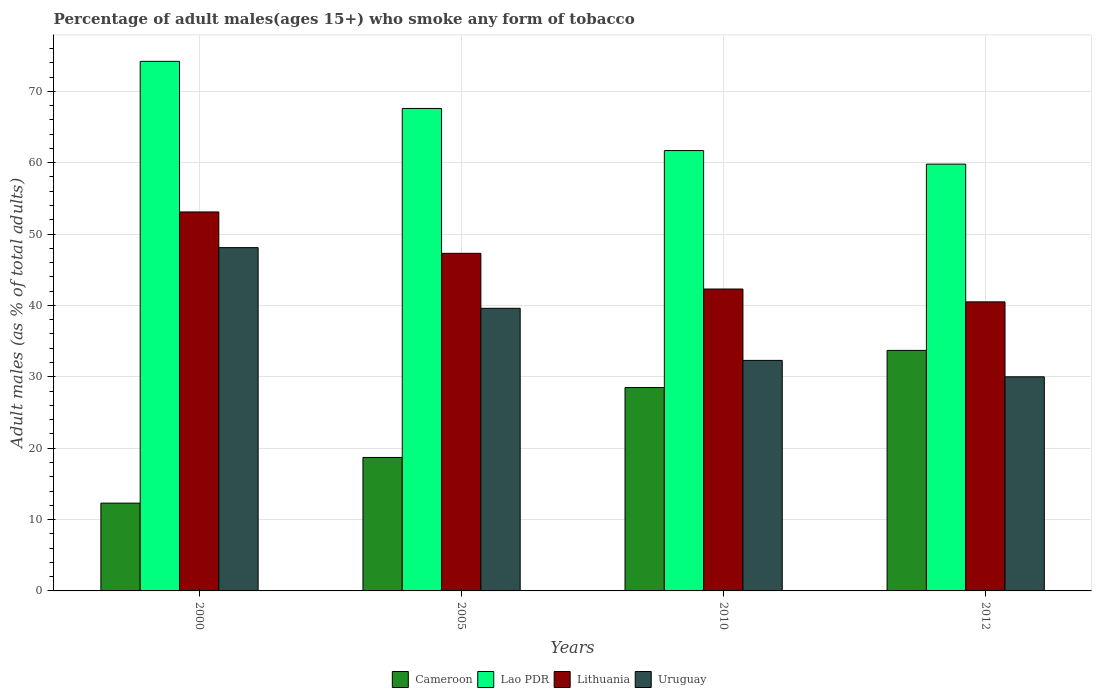How many different coloured bars are there?
Ensure brevity in your answer.  4. How many groups of bars are there?
Ensure brevity in your answer.  4. Are the number of bars per tick equal to the number of legend labels?
Your answer should be very brief. Yes. What is the label of the 3rd group of bars from the left?
Give a very brief answer. 2010. Across all years, what is the maximum percentage of adult males who smoke in Uruguay?
Your response must be concise. 48.1. Across all years, what is the minimum percentage of adult males who smoke in Cameroon?
Provide a short and direct response. 12.3. In which year was the percentage of adult males who smoke in Lao PDR maximum?
Provide a succinct answer. 2000. In which year was the percentage of adult males who smoke in Lithuania minimum?
Your answer should be very brief. 2012. What is the total percentage of adult males who smoke in Lithuania in the graph?
Your answer should be very brief. 183.2. What is the difference between the percentage of adult males who smoke in Uruguay in 2005 and the percentage of adult males who smoke in Lithuania in 2012?
Your answer should be compact. -0.9. What is the average percentage of adult males who smoke in Lithuania per year?
Provide a short and direct response. 45.8. In the year 2005, what is the difference between the percentage of adult males who smoke in Lithuania and percentage of adult males who smoke in Lao PDR?
Your answer should be very brief. -20.3. In how many years, is the percentage of adult males who smoke in Lao PDR greater than 66 %?
Your response must be concise. 2. What is the ratio of the percentage of adult males who smoke in Lithuania in 2000 to that in 2010?
Your answer should be very brief. 1.26. Is the percentage of adult males who smoke in Cameroon in 2005 less than that in 2012?
Your answer should be compact. Yes. Is the difference between the percentage of adult males who smoke in Lithuania in 2000 and 2005 greater than the difference between the percentage of adult males who smoke in Lao PDR in 2000 and 2005?
Provide a short and direct response. No. What is the difference between the highest and the second highest percentage of adult males who smoke in Lao PDR?
Your answer should be compact. 6.6. What is the difference between the highest and the lowest percentage of adult males who smoke in Uruguay?
Provide a succinct answer. 18.1. In how many years, is the percentage of adult males who smoke in Lithuania greater than the average percentage of adult males who smoke in Lithuania taken over all years?
Give a very brief answer. 2. Is the sum of the percentage of adult males who smoke in Cameroon in 2005 and 2012 greater than the maximum percentage of adult males who smoke in Uruguay across all years?
Give a very brief answer. Yes. Is it the case that in every year, the sum of the percentage of adult males who smoke in Uruguay and percentage of adult males who smoke in Lithuania is greater than the sum of percentage of adult males who smoke in Lao PDR and percentage of adult males who smoke in Cameroon?
Keep it short and to the point. No. What does the 1st bar from the left in 2000 represents?
Provide a short and direct response. Cameroon. What does the 2nd bar from the right in 2012 represents?
Provide a succinct answer. Lithuania. Is it the case that in every year, the sum of the percentage of adult males who smoke in Lithuania and percentage of adult males who smoke in Uruguay is greater than the percentage of adult males who smoke in Cameroon?
Ensure brevity in your answer.  Yes. How many bars are there?
Your response must be concise. 16. What is the difference between two consecutive major ticks on the Y-axis?
Give a very brief answer. 10. Are the values on the major ticks of Y-axis written in scientific E-notation?
Ensure brevity in your answer.  No. Does the graph contain any zero values?
Your answer should be compact. No. Where does the legend appear in the graph?
Ensure brevity in your answer.  Bottom center. How are the legend labels stacked?
Give a very brief answer. Horizontal. What is the title of the graph?
Your answer should be very brief. Percentage of adult males(ages 15+) who smoke any form of tobacco. What is the label or title of the X-axis?
Provide a short and direct response. Years. What is the label or title of the Y-axis?
Provide a succinct answer. Adult males (as % of total adults). What is the Adult males (as % of total adults) in Cameroon in 2000?
Your response must be concise. 12.3. What is the Adult males (as % of total adults) in Lao PDR in 2000?
Give a very brief answer. 74.2. What is the Adult males (as % of total adults) in Lithuania in 2000?
Your answer should be very brief. 53.1. What is the Adult males (as % of total adults) in Uruguay in 2000?
Offer a terse response. 48.1. What is the Adult males (as % of total adults) of Lao PDR in 2005?
Provide a succinct answer. 67.6. What is the Adult males (as % of total adults) in Lithuania in 2005?
Your answer should be very brief. 47.3. What is the Adult males (as % of total adults) of Uruguay in 2005?
Offer a very short reply. 39.6. What is the Adult males (as % of total adults) of Cameroon in 2010?
Provide a succinct answer. 28.5. What is the Adult males (as % of total adults) of Lao PDR in 2010?
Provide a short and direct response. 61.7. What is the Adult males (as % of total adults) of Lithuania in 2010?
Provide a short and direct response. 42.3. What is the Adult males (as % of total adults) in Uruguay in 2010?
Offer a terse response. 32.3. What is the Adult males (as % of total adults) in Cameroon in 2012?
Make the answer very short. 33.7. What is the Adult males (as % of total adults) of Lao PDR in 2012?
Give a very brief answer. 59.8. What is the Adult males (as % of total adults) in Lithuania in 2012?
Keep it short and to the point. 40.5. Across all years, what is the maximum Adult males (as % of total adults) in Cameroon?
Offer a very short reply. 33.7. Across all years, what is the maximum Adult males (as % of total adults) in Lao PDR?
Provide a short and direct response. 74.2. Across all years, what is the maximum Adult males (as % of total adults) of Lithuania?
Your answer should be compact. 53.1. Across all years, what is the maximum Adult males (as % of total adults) of Uruguay?
Give a very brief answer. 48.1. Across all years, what is the minimum Adult males (as % of total adults) in Lao PDR?
Offer a very short reply. 59.8. Across all years, what is the minimum Adult males (as % of total adults) of Lithuania?
Ensure brevity in your answer.  40.5. What is the total Adult males (as % of total adults) of Cameroon in the graph?
Your response must be concise. 93.2. What is the total Adult males (as % of total adults) of Lao PDR in the graph?
Provide a short and direct response. 263.3. What is the total Adult males (as % of total adults) of Lithuania in the graph?
Your response must be concise. 183.2. What is the total Adult males (as % of total adults) of Uruguay in the graph?
Keep it short and to the point. 150. What is the difference between the Adult males (as % of total adults) of Cameroon in 2000 and that in 2005?
Offer a very short reply. -6.4. What is the difference between the Adult males (as % of total adults) of Lao PDR in 2000 and that in 2005?
Your answer should be compact. 6.6. What is the difference between the Adult males (as % of total adults) in Cameroon in 2000 and that in 2010?
Offer a very short reply. -16.2. What is the difference between the Adult males (as % of total adults) in Uruguay in 2000 and that in 2010?
Offer a very short reply. 15.8. What is the difference between the Adult males (as % of total adults) of Cameroon in 2000 and that in 2012?
Ensure brevity in your answer.  -21.4. What is the difference between the Adult males (as % of total adults) in Uruguay in 2005 and that in 2010?
Provide a short and direct response. 7.3. What is the difference between the Adult males (as % of total adults) of Cameroon in 2005 and that in 2012?
Provide a short and direct response. -15. What is the difference between the Adult males (as % of total adults) in Lithuania in 2005 and that in 2012?
Ensure brevity in your answer.  6.8. What is the difference between the Adult males (as % of total adults) of Lao PDR in 2010 and that in 2012?
Your response must be concise. 1.9. What is the difference between the Adult males (as % of total adults) in Lithuania in 2010 and that in 2012?
Make the answer very short. 1.8. What is the difference between the Adult males (as % of total adults) in Uruguay in 2010 and that in 2012?
Offer a terse response. 2.3. What is the difference between the Adult males (as % of total adults) of Cameroon in 2000 and the Adult males (as % of total adults) of Lao PDR in 2005?
Ensure brevity in your answer.  -55.3. What is the difference between the Adult males (as % of total adults) in Cameroon in 2000 and the Adult males (as % of total adults) in Lithuania in 2005?
Offer a terse response. -35. What is the difference between the Adult males (as % of total adults) of Cameroon in 2000 and the Adult males (as % of total adults) of Uruguay in 2005?
Keep it short and to the point. -27.3. What is the difference between the Adult males (as % of total adults) of Lao PDR in 2000 and the Adult males (as % of total adults) of Lithuania in 2005?
Your response must be concise. 26.9. What is the difference between the Adult males (as % of total adults) in Lao PDR in 2000 and the Adult males (as % of total adults) in Uruguay in 2005?
Your response must be concise. 34.6. What is the difference between the Adult males (as % of total adults) in Lithuania in 2000 and the Adult males (as % of total adults) in Uruguay in 2005?
Keep it short and to the point. 13.5. What is the difference between the Adult males (as % of total adults) of Cameroon in 2000 and the Adult males (as % of total adults) of Lao PDR in 2010?
Your response must be concise. -49.4. What is the difference between the Adult males (as % of total adults) of Cameroon in 2000 and the Adult males (as % of total adults) of Lithuania in 2010?
Provide a short and direct response. -30. What is the difference between the Adult males (as % of total adults) in Lao PDR in 2000 and the Adult males (as % of total adults) in Lithuania in 2010?
Offer a terse response. 31.9. What is the difference between the Adult males (as % of total adults) in Lao PDR in 2000 and the Adult males (as % of total adults) in Uruguay in 2010?
Make the answer very short. 41.9. What is the difference between the Adult males (as % of total adults) in Lithuania in 2000 and the Adult males (as % of total adults) in Uruguay in 2010?
Your answer should be very brief. 20.8. What is the difference between the Adult males (as % of total adults) of Cameroon in 2000 and the Adult males (as % of total adults) of Lao PDR in 2012?
Give a very brief answer. -47.5. What is the difference between the Adult males (as % of total adults) of Cameroon in 2000 and the Adult males (as % of total adults) of Lithuania in 2012?
Offer a very short reply. -28.2. What is the difference between the Adult males (as % of total adults) in Cameroon in 2000 and the Adult males (as % of total adults) in Uruguay in 2012?
Offer a very short reply. -17.7. What is the difference between the Adult males (as % of total adults) of Lao PDR in 2000 and the Adult males (as % of total adults) of Lithuania in 2012?
Offer a terse response. 33.7. What is the difference between the Adult males (as % of total adults) in Lao PDR in 2000 and the Adult males (as % of total adults) in Uruguay in 2012?
Your answer should be compact. 44.2. What is the difference between the Adult males (as % of total adults) of Lithuania in 2000 and the Adult males (as % of total adults) of Uruguay in 2012?
Your answer should be compact. 23.1. What is the difference between the Adult males (as % of total adults) of Cameroon in 2005 and the Adult males (as % of total adults) of Lao PDR in 2010?
Your response must be concise. -43. What is the difference between the Adult males (as % of total adults) of Cameroon in 2005 and the Adult males (as % of total adults) of Lithuania in 2010?
Keep it short and to the point. -23.6. What is the difference between the Adult males (as % of total adults) of Lao PDR in 2005 and the Adult males (as % of total adults) of Lithuania in 2010?
Make the answer very short. 25.3. What is the difference between the Adult males (as % of total adults) of Lao PDR in 2005 and the Adult males (as % of total adults) of Uruguay in 2010?
Offer a terse response. 35.3. What is the difference between the Adult males (as % of total adults) of Lithuania in 2005 and the Adult males (as % of total adults) of Uruguay in 2010?
Offer a terse response. 15. What is the difference between the Adult males (as % of total adults) of Cameroon in 2005 and the Adult males (as % of total adults) of Lao PDR in 2012?
Your answer should be compact. -41.1. What is the difference between the Adult males (as % of total adults) in Cameroon in 2005 and the Adult males (as % of total adults) in Lithuania in 2012?
Give a very brief answer. -21.8. What is the difference between the Adult males (as % of total adults) in Cameroon in 2005 and the Adult males (as % of total adults) in Uruguay in 2012?
Offer a very short reply. -11.3. What is the difference between the Adult males (as % of total adults) of Lao PDR in 2005 and the Adult males (as % of total adults) of Lithuania in 2012?
Provide a short and direct response. 27.1. What is the difference between the Adult males (as % of total adults) of Lao PDR in 2005 and the Adult males (as % of total adults) of Uruguay in 2012?
Ensure brevity in your answer.  37.6. What is the difference between the Adult males (as % of total adults) of Lithuania in 2005 and the Adult males (as % of total adults) of Uruguay in 2012?
Provide a short and direct response. 17.3. What is the difference between the Adult males (as % of total adults) in Cameroon in 2010 and the Adult males (as % of total adults) in Lao PDR in 2012?
Your answer should be compact. -31.3. What is the difference between the Adult males (as % of total adults) in Cameroon in 2010 and the Adult males (as % of total adults) in Lithuania in 2012?
Ensure brevity in your answer.  -12. What is the difference between the Adult males (as % of total adults) in Cameroon in 2010 and the Adult males (as % of total adults) in Uruguay in 2012?
Give a very brief answer. -1.5. What is the difference between the Adult males (as % of total adults) in Lao PDR in 2010 and the Adult males (as % of total adults) in Lithuania in 2012?
Offer a terse response. 21.2. What is the difference between the Adult males (as % of total adults) in Lao PDR in 2010 and the Adult males (as % of total adults) in Uruguay in 2012?
Your answer should be compact. 31.7. What is the average Adult males (as % of total adults) of Cameroon per year?
Your response must be concise. 23.3. What is the average Adult males (as % of total adults) in Lao PDR per year?
Offer a very short reply. 65.83. What is the average Adult males (as % of total adults) of Lithuania per year?
Offer a terse response. 45.8. What is the average Adult males (as % of total adults) in Uruguay per year?
Your answer should be very brief. 37.5. In the year 2000, what is the difference between the Adult males (as % of total adults) of Cameroon and Adult males (as % of total adults) of Lao PDR?
Ensure brevity in your answer.  -61.9. In the year 2000, what is the difference between the Adult males (as % of total adults) in Cameroon and Adult males (as % of total adults) in Lithuania?
Provide a succinct answer. -40.8. In the year 2000, what is the difference between the Adult males (as % of total adults) in Cameroon and Adult males (as % of total adults) in Uruguay?
Give a very brief answer. -35.8. In the year 2000, what is the difference between the Adult males (as % of total adults) in Lao PDR and Adult males (as % of total adults) in Lithuania?
Your answer should be compact. 21.1. In the year 2000, what is the difference between the Adult males (as % of total adults) of Lao PDR and Adult males (as % of total adults) of Uruguay?
Your answer should be compact. 26.1. In the year 2005, what is the difference between the Adult males (as % of total adults) of Cameroon and Adult males (as % of total adults) of Lao PDR?
Your response must be concise. -48.9. In the year 2005, what is the difference between the Adult males (as % of total adults) of Cameroon and Adult males (as % of total adults) of Lithuania?
Give a very brief answer. -28.6. In the year 2005, what is the difference between the Adult males (as % of total adults) of Cameroon and Adult males (as % of total adults) of Uruguay?
Provide a short and direct response. -20.9. In the year 2005, what is the difference between the Adult males (as % of total adults) of Lao PDR and Adult males (as % of total adults) of Lithuania?
Keep it short and to the point. 20.3. In the year 2005, what is the difference between the Adult males (as % of total adults) in Lao PDR and Adult males (as % of total adults) in Uruguay?
Give a very brief answer. 28. In the year 2005, what is the difference between the Adult males (as % of total adults) of Lithuania and Adult males (as % of total adults) of Uruguay?
Offer a very short reply. 7.7. In the year 2010, what is the difference between the Adult males (as % of total adults) of Cameroon and Adult males (as % of total adults) of Lao PDR?
Offer a terse response. -33.2. In the year 2010, what is the difference between the Adult males (as % of total adults) of Cameroon and Adult males (as % of total adults) of Lithuania?
Your response must be concise. -13.8. In the year 2010, what is the difference between the Adult males (as % of total adults) in Cameroon and Adult males (as % of total adults) in Uruguay?
Offer a very short reply. -3.8. In the year 2010, what is the difference between the Adult males (as % of total adults) in Lao PDR and Adult males (as % of total adults) in Lithuania?
Your answer should be very brief. 19.4. In the year 2010, what is the difference between the Adult males (as % of total adults) of Lao PDR and Adult males (as % of total adults) of Uruguay?
Offer a terse response. 29.4. In the year 2010, what is the difference between the Adult males (as % of total adults) in Lithuania and Adult males (as % of total adults) in Uruguay?
Make the answer very short. 10. In the year 2012, what is the difference between the Adult males (as % of total adults) of Cameroon and Adult males (as % of total adults) of Lao PDR?
Keep it short and to the point. -26.1. In the year 2012, what is the difference between the Adult males (as % of total adults) in Cameroon and Adult males (as % of total adults) in Lithuania?
Your answer should be very brief. -6.8. In the year 2012, what is the difference between the Adult males (as % of total adults) of Lao PDR and Adult males (as % of total adults) of Lithuania?
Offer a terse response. 19.3. In the year 2012, what is the difference between the Adult males (as % of total adults) in Lao PDR and Adult males (as % of total adults) in Uruguay?
Offer a very short reply. 29.8. In the year 2012, what is the difference between the Adult males (as % of total adults) of Lithuania and Adult males (as % of total adults) of Uruguay?
Provide a short and direct response. 10.5. What is the ratio of the Adult males (as % of total adults) in Cameroon in 2000 to that in 2005?
Provide a short and direct response. 0.66. What is the ratio of the Adult males (as % of total adults) in Lao PDR in 2000 to that in 2005?
Give a very brief answer. 1.1. What is the ratio of the Adult males (as % of total adults) in Lithuania in 2000 to that in 2005?
Provide a short and direct response. 1.12. What is the ratio of the Adult males (as % of total adults) of Uruguay in 2000 to that in 2005?
Keep it short and to the point. 1.21. What is the ratio of the Adult males (as % of total adults) of Cameroon in 2000 to that in 2010?
Keep it short and to the point. 0.43. What is the ratio of the Adult males (as % of total adults) of Lao PDR in 2000 to that in 2010?
Provide a short and direct response. 1.2. What is the ratio of the Adult males (as % of total adults) of Lithuania in 2000 to that in 2010?
Offer a very short reply. 1.26. What is the ratio of the Adult males (as % of total adults) of Uruguay in 2000 to that in 2010?
Offer a very short reply. 1.49. What is the ratio of the Adult males (as % of total adults) in Cameroon in 2000 to that in 2012?
Ensure brevity in your answer.  0.36. What is the ratio of the Adult males (as % of total adults) in Lao PDR in 2000 to that in 2012?
Give a very brief answer. 1.24. What is the ratio of the Adult males (as % of total adults) of Lithuania in 2000 to that in 2012?
Offer a very short reply. 1.31. What is the ratio of the Adult males (as % of total adults) of Uruguay in 2000 to that in 2012?
Your answer should be very brief. 1.6. What is the ratio of the Adult males (as % of total adults) in Cameroon in 2005 to that in 2010?
Your answer should be very brief. 0.66. What is the ratio of the Adult males (as % of total adults) in Lao PDR in 2005 to that in 2010?
Your answer should be compact. 1.1. What is the ratio of the Adult males (as % of total adults) in Lithuania in 2005 to that in 2010?
Ensure brevity in your answer.  1.12. What is the ratio of the Adult males (as % of total adults) of Uruguay in 2005 to that in 2010?
Make the answer very short. 1.23. What is the ratio of the Adult males (as % of total adults) in Cameroon in 2005 to that in 2012?
Your response must be concise. 0.55. What is the ratio of the Adult males (as % of total adults) in Lao PDR in 2005 to that in 2012?
Make the answer very short. 1.13. What is the ratio of the Adult males (as % of total adults) of Lithuania in 2005 to that in 2012?
Keep it short and to the point. 1.17. What is the ratio of the Adult males (as % of total adults) in Uruguay in 2005 to that in 2012?
Provide a succinct answer. 1.32. What is the ratio of the Adult males (as % of total adults) in Cameroon in 2010 to that in 2012?
Your response must be concise. 0.85. What is the ratio of the Adult males (as % of total adults) of Lao PDR in 2010 to that in 2012?
Ensure brevity in your answer.  1.03. What is the ratio of the Adult males (as % of total adults) of Lithuania in 2010 to that in 2012?
Give a very brief answer. 1.04. What is the ratio of the Adult males (as % of total adults) in Uruguay in 2010 to that in 2012?
Ensure brevity in your answer.  1.08. What is the difference between the highest and the second highest Adult males (as % of total adults) in Lao PDR?
Offer a very short reply. 6.6. What is the difference between the highest and the second highest Adult males (as % of total adults) of Uruguay?
Offer a terse response. 8.5. What is the difference between the highest and the lowest Adult males (as % of total adults) in Cameroon?
Provide a succinct answer. 21.4. What is the difference between the highest and the lowest Adult males (as % of total adults) in Lao PDR?
Your answer should be very brief. 14.4. What is the difference between the highest and the lowest Adult males (as % of total adults) in Uruguay?
Ensure brevity in your answer.  18.1. 